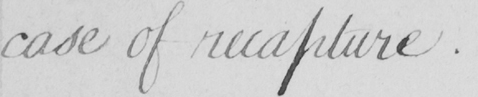What does this handwritten line say? case of recapture . 